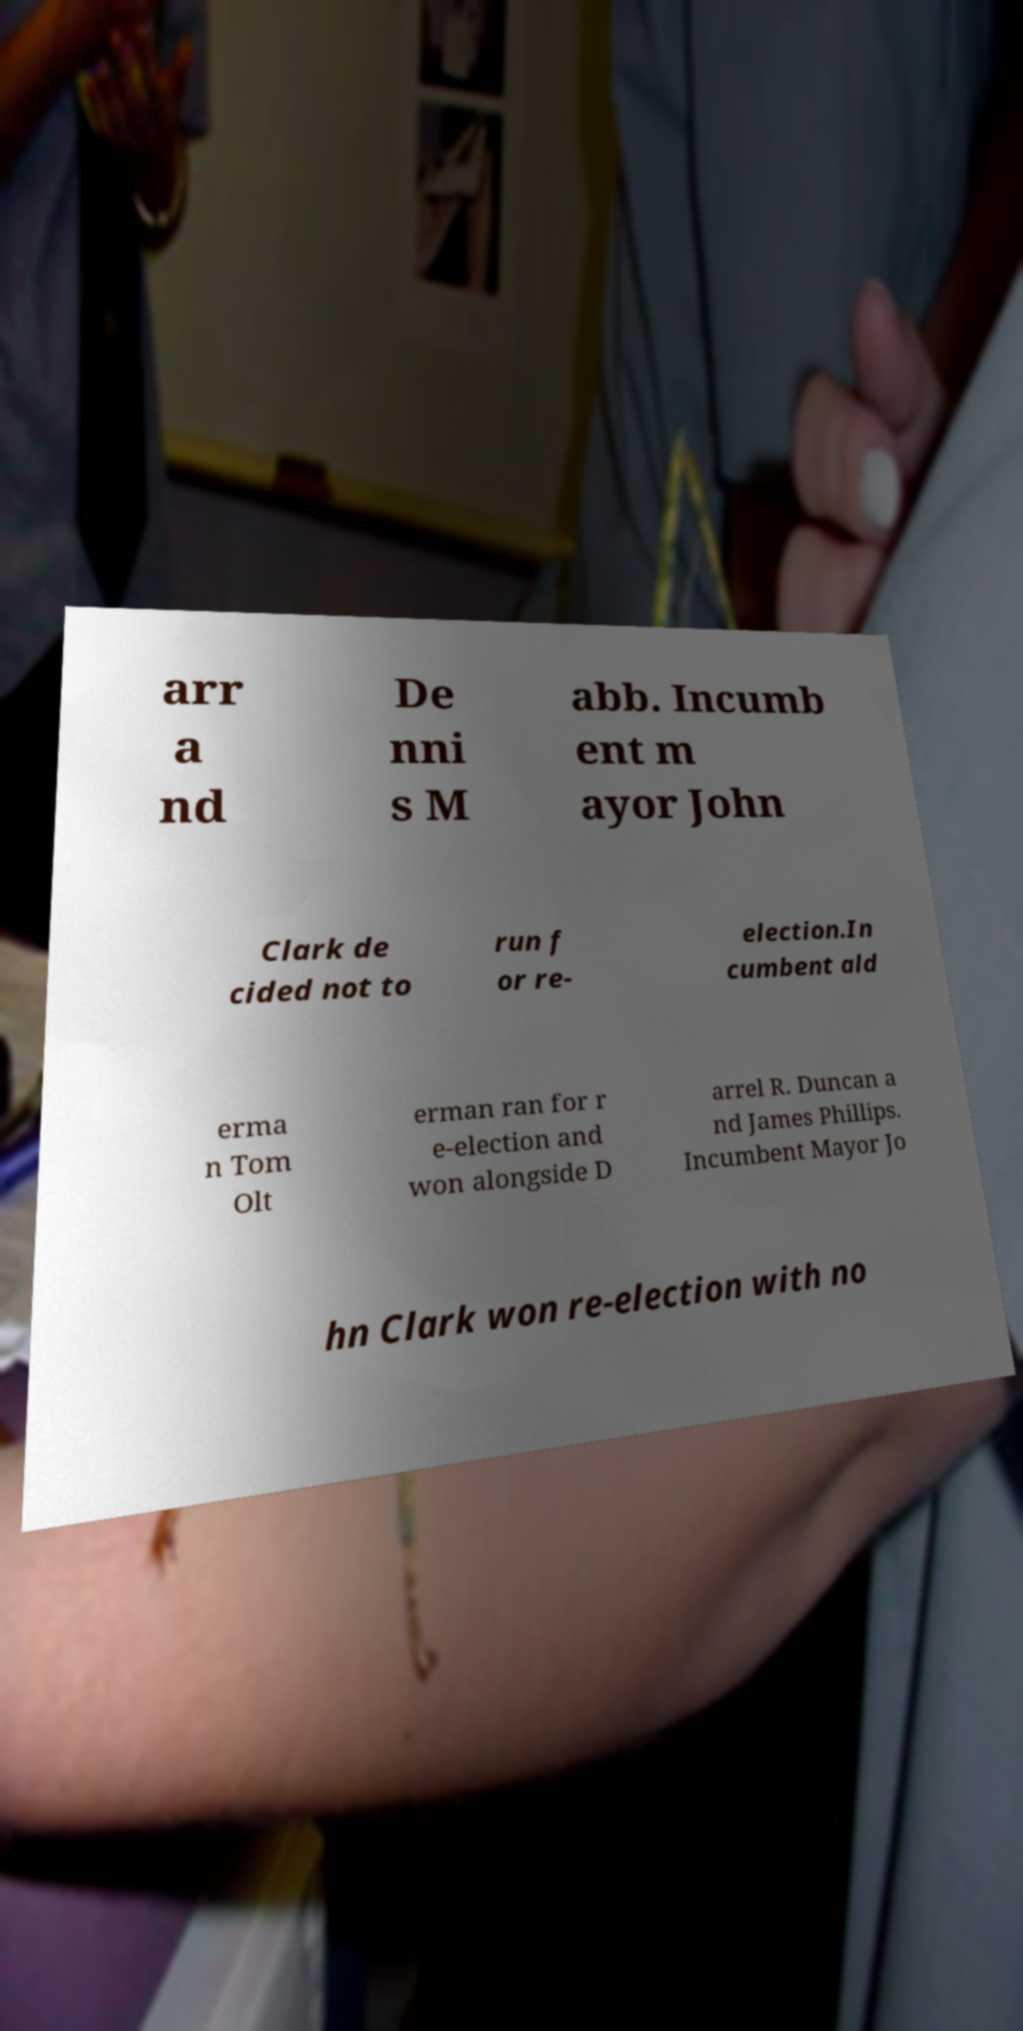Can you read and provide the text displayed in the image?This photo seems to have some interesting text. Can you extract and type it out for me? arr a nd De nni s M abb. Incumb ent m ayor John Clark de cided not to run f or re- election.In cumbent ald erma n Tom Olt erman ran for r e-election and won alongside D arrel R. Duncan a nd James Phillips. Incumbent Mayor Jo hn Clark won re-election with no 